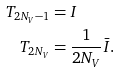Convert formula to latex. <formula><loc_0><loc_0><loc_500><loc_500>T _ { 2 N _ { V } - 1 } & = I \\ T _ { 2 N _ { V } } & = \frac { 1 } { 2 N _ { V } } \bar { I } .</formula> 